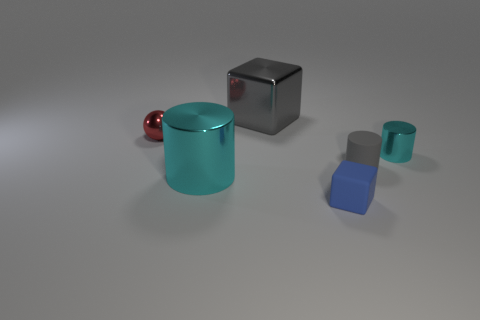Is there a cylinder made of the same material as the blue cube?
Offer a terse response. Yes. Do the red metallic ball and the gray metal cube have the same size?
Make the answer very short. No. What number of cylinders are either gray matte objects or gray objects?
Give a very brief answer. 1. There is a object that is the same color as the large metal cylinder; what is it made of?
Your response must be concise. Metal. What number of large metallic things have the same shape as the tiny gray rubber thing?
Your answer should be very brief. 1. Are there more gray objects that are in front of the small shiny ball than large things right of the small gray matte object?
Offer a very short reply. Yes. Does the large object behind the large cyan metallic object have the same color as the big cylinder?
Your answer should be compact. No. How big is the metallic cube?
Make the answer very short. Large. There is a ball that is the same size as the gray cylinder; what material is it?
Keep it short and to the point. Metal. What is the color of the small shiny object that is right of the tiny gray rubber cylinder?
Offer a very short reply. Cyan. 